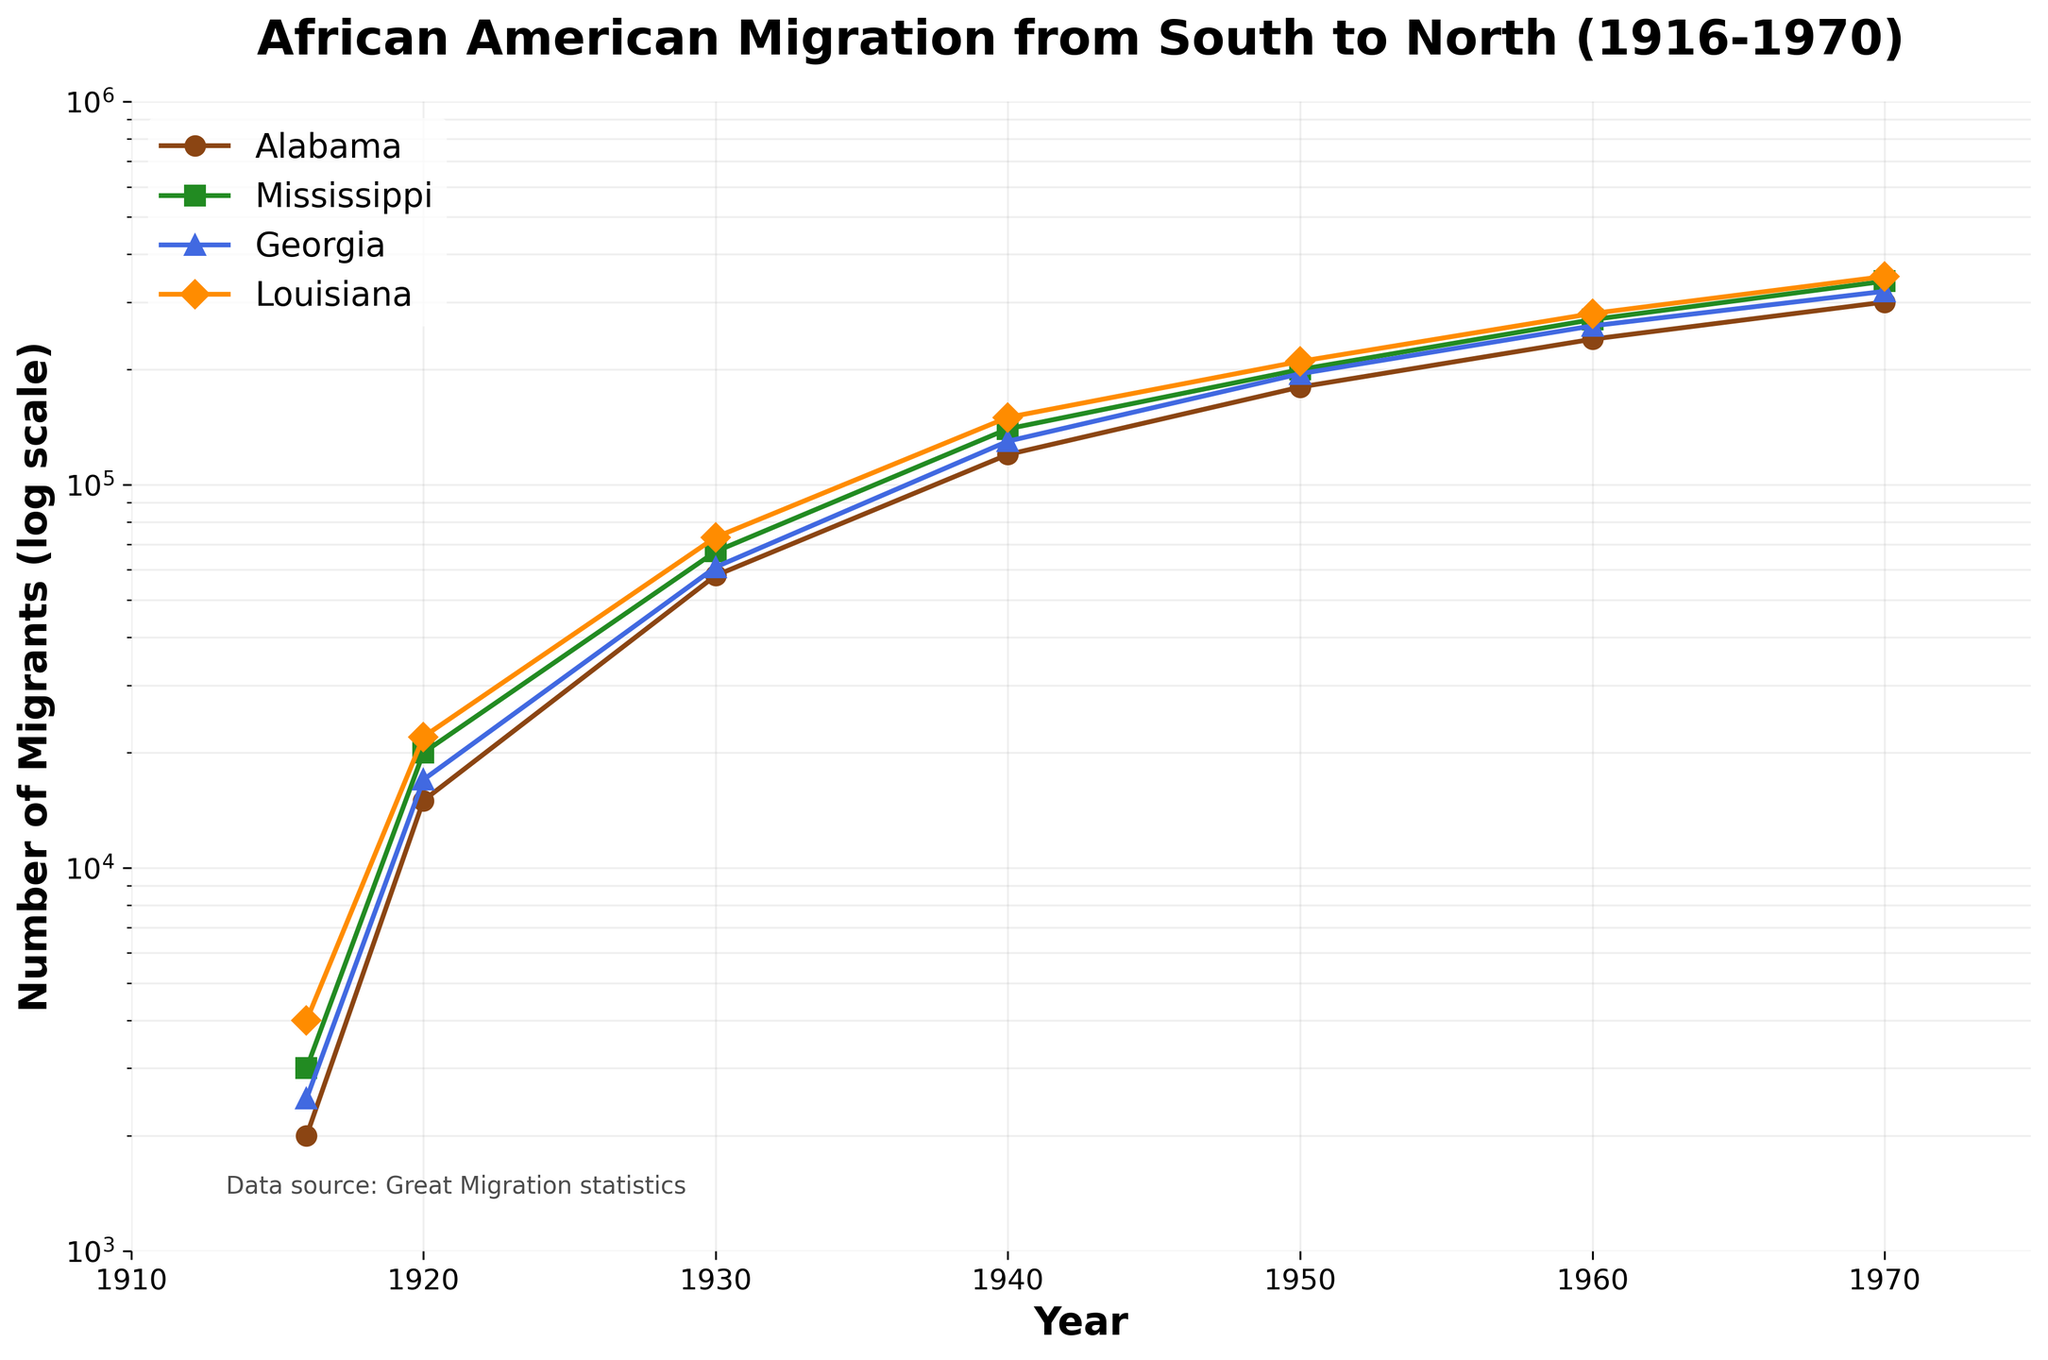What is the title of the plot? The title is located at the top center of the plot and provides an overview of the data represented.
Answer: African American Migration from South to North (1916-1970) What is the scale of the y-axis? The y-axis is marked with a special notation, indicating that it uses a logarithmic scale for the number of migrants.
Answer: Logarithmic scale Which region had the highest number of migrants in 1970? By looking at the data points for the year 1970 across all regions, the plot shows that Louisiana had the highest number of migrants.
Answer: Louisiana Between which years did Alabama see the largest increase in migrants? Comparing the slopes of the lines for Alabama between adjacent years, the steepest increase happens between 1930 and 1940 based on the spacing of points on the logarithmic scale.
Answer: 1930 and 1940 How does the migration trend of Georgia compare to Mississippi over the entire period? By observing the overall shapes and trajectories of the lines for Georgia and Mississippi, they show quite similar trends, with Georgia consistently having fewer migrants than Mississippi after 1930.
Answer: Georgia has fewer migrants than Mississippi Which year marks the beginning of a noticeable increase in the migration for all regions? Analyzing the positions and slopes of the lines, a noticeable increase begins around 1940 for all regions, where the lines start to rise sharply.
Answer: 1940 What is the total number of migrants from Alabama and Mississippi in 1930? Adding the number of migrants for Alabama (58000) and Mississippi (67000) shown on the plot for the year 1930 gives us the total number.
Answer: 125000 What pattern can be seen in the migration trends from 1916 to 1970? Observing the overall trend across all regions shows a roughly exponential increase, as evidenced by the consistent steepening of the lines over time.
Answer: Exponential increase Which two regions had similar migration patterns? By close inspection of the plot, the migration patterns of Georgia and Alabama are quite similar, following almost parallel trajectories.
Answer: Georgia and Alabama What does the x-axis represent? The x-axis labels range from 1910 to 1975, indicating that it represents years of the period being studied.
Answer: Year 